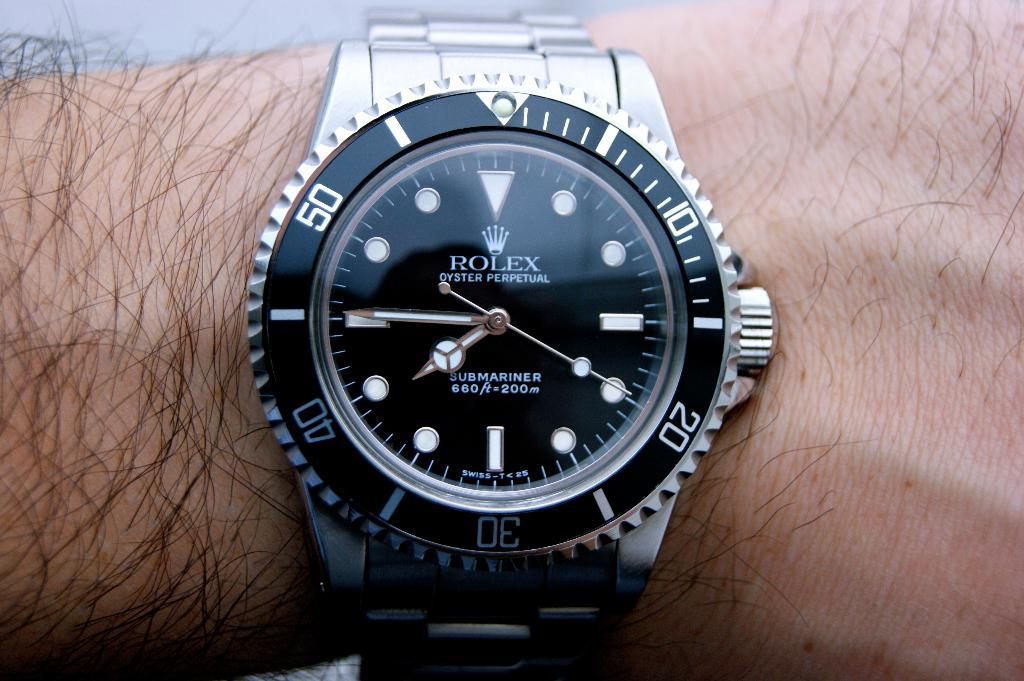What brand is the watch?
Provide a short and direct response. Rolex. What number is the second hand pointing closest to?
Ensure brevity in your answer.  20. 